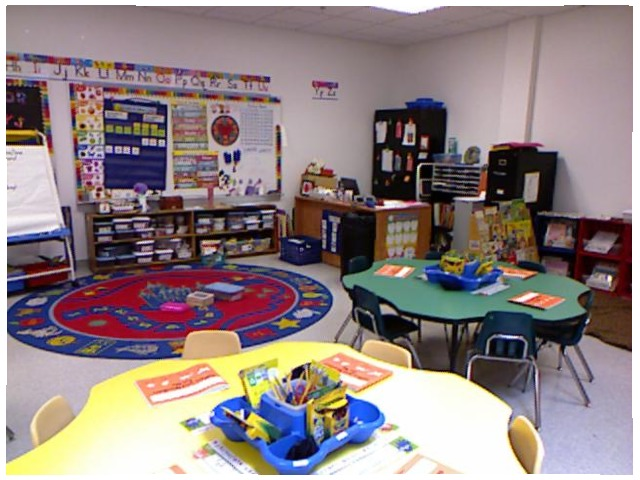<image>
Can you confirm if the chair is under the table? Yes. The chair is positioned underneath the table, with the table above it in the vertical space. Where is the chair in relation to the table? Is it under the table? No. The chair is not positioned under the table. The vertical relationship between these objects is different. Is the letters on the wall? Yes. Looking at the image, I can see the letters is positioned on top of the wall, with the wall providing support. Is there a mat on the table? No. The mat is not positioned on the table. They may be near each other, but the mat is not supported by or resting on top of the table. Where is the chair in relation to the table? Is it to the left of the table? No. The chair is not to the left of the table. From this viewpoint, they have a different horizontal relationship. 